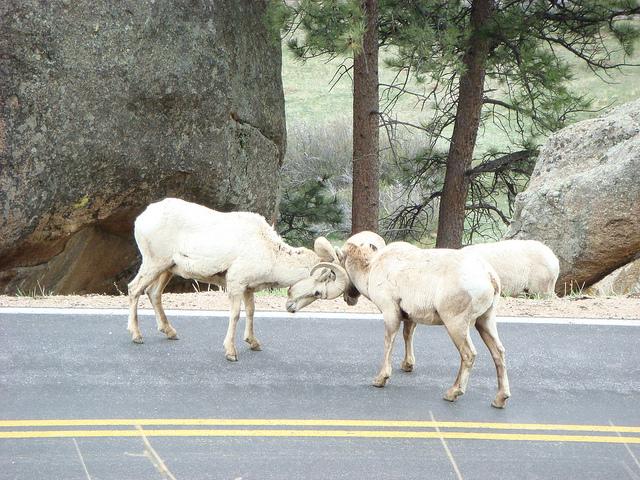What are the animals doing?
Be succinct. Fighting. Are these animals concerned with oncoming traffic?
Answer briefly. No. How many animals are in this photo?
Be succinct. 3. 